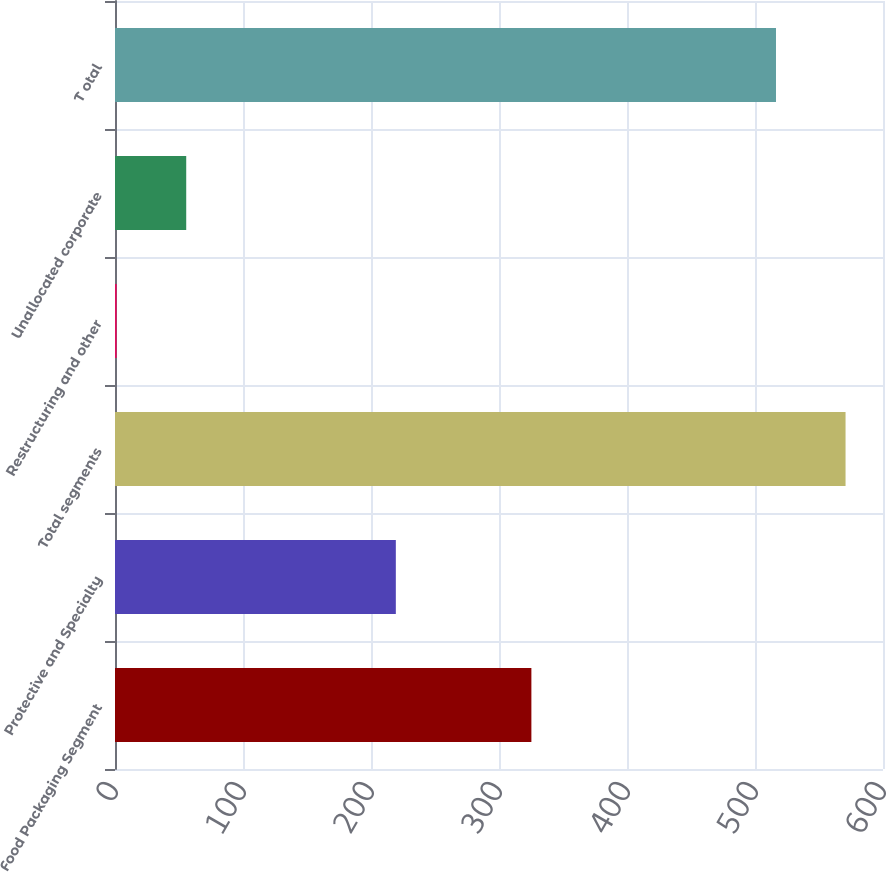<chart> <loc_0><loc_0><loc_500><loc_500><bar_chart><fcel>Food Packaging Segment<fcel>Protective and Specialty<fcel>Total segments<fcel>Restructuring and other<fcel>Unallocated corporate<fcel>T otal<nl><fcel>325.3<fcel>219.4<fcel>570.74<fcel>1.3<fcel>55.64<fcel>516.4<nl></chart> 